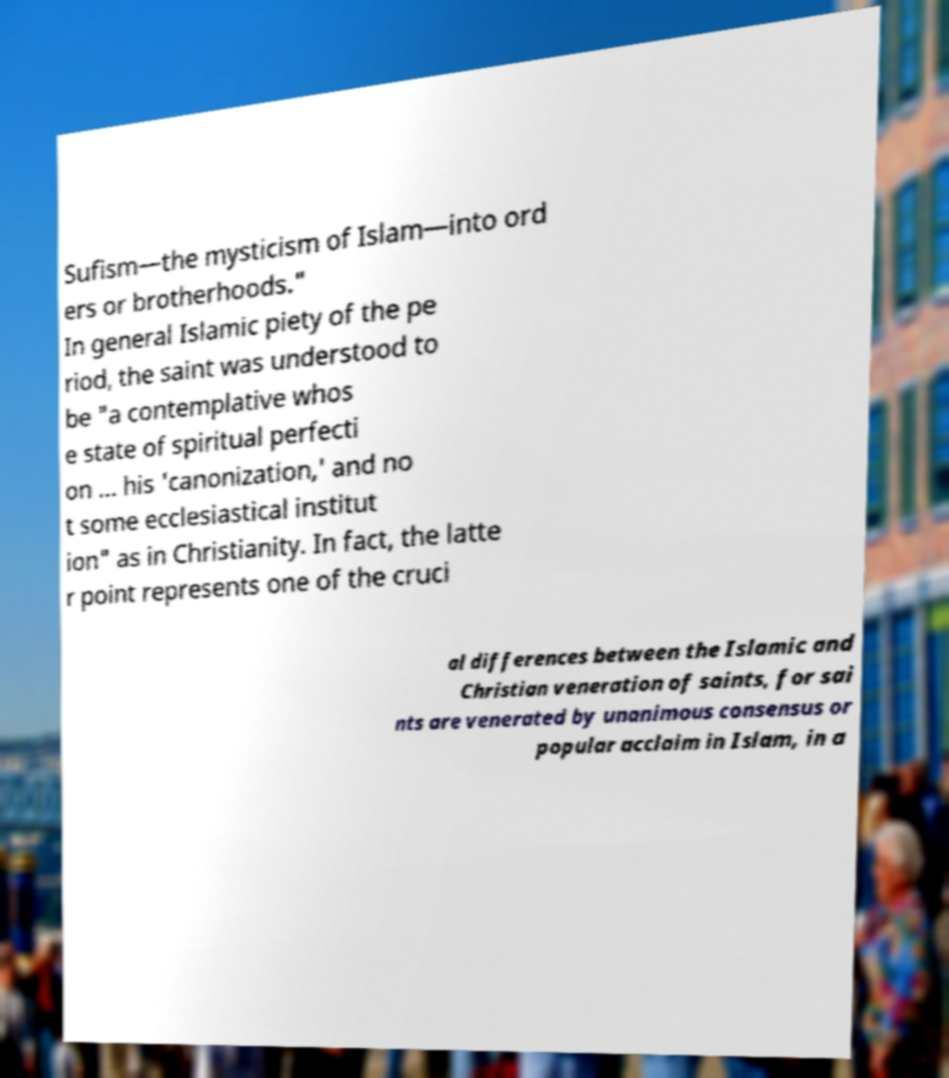Can you accurately transcribe the text from the provided image for me? Sufism—the mysticism of Islam—into ord ers or brotherhoods." In general Islamic piety of the pe riod, the saint was understood to be "a contemplative whos e state of spiritual perfecti on ... his 'canonization,' and no t some ecclesiastical institut ion" as in Christianity. In fact, the latte r point represents one of the cruci al differences between the Islamic and Christian veneration of saints, for sai nts are venerated by unanimous consensus or popular acclaim in Islam, in a 